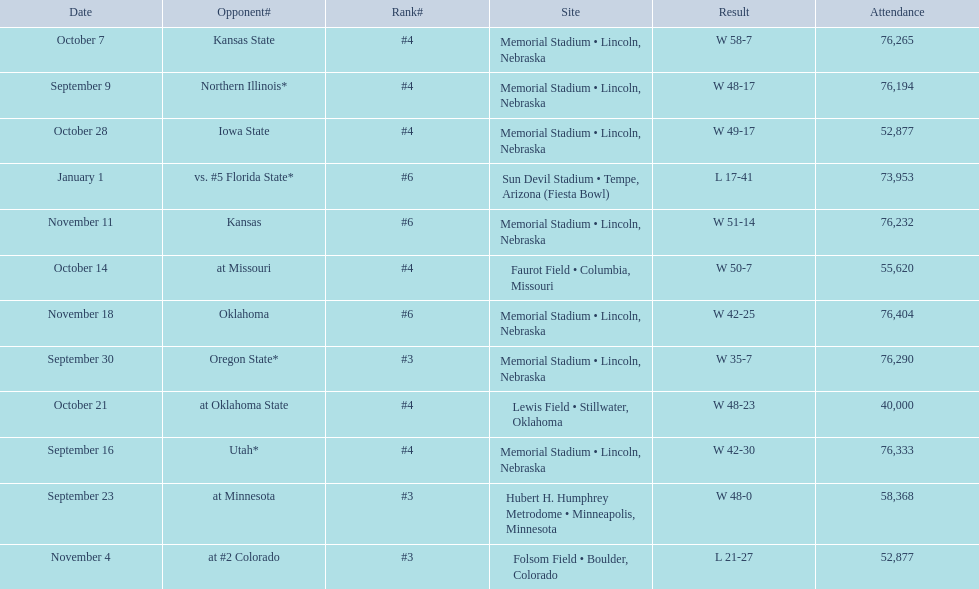Who were all of their opponents? Northern Illinois*, Utah*, at Minnesota, Oregon State*, Kansas State, at Missouri, at Oklahoma State, Iowa State, at #2 Colorado, Kansas, Oklahoma, vs. #5 Florida State*. And what was the attendance of these games? 76,194, 76,333, 58,368, 76,290, 76,265, 55,620, 40,000, 52,877, 52,877, 76,232, 76,404, 73,953. Of those numbers, which is associated with the oregon state game? 76,290. 